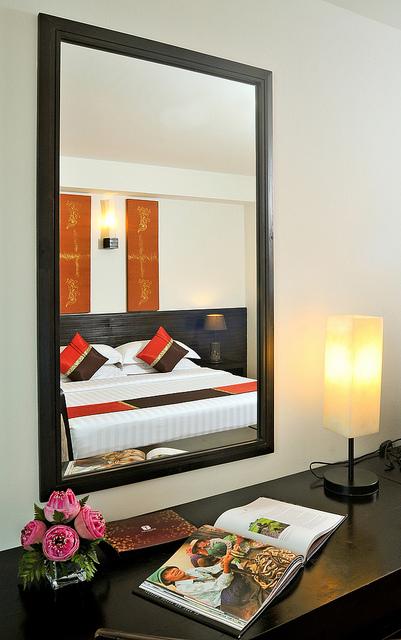How many books?
Concise answer only. 1. Is there a television on the table?
Give a very brief answer. No. What reflection is in the mirror?
Give a very brief answer. Bed. What is black and white and large on the wall?
Keep it brief. Mirror. 